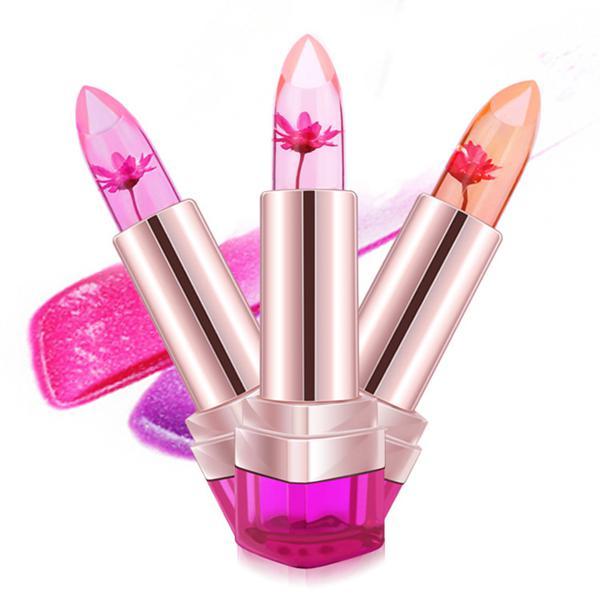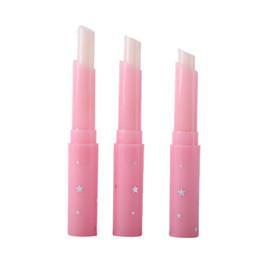The first image is the image on the left, the second image is the image on the right. Evaluate the accuracy of this statement regarding the images: "An image shows a lipstick by colored lips.". Is it true? Answer yes or no. No. 